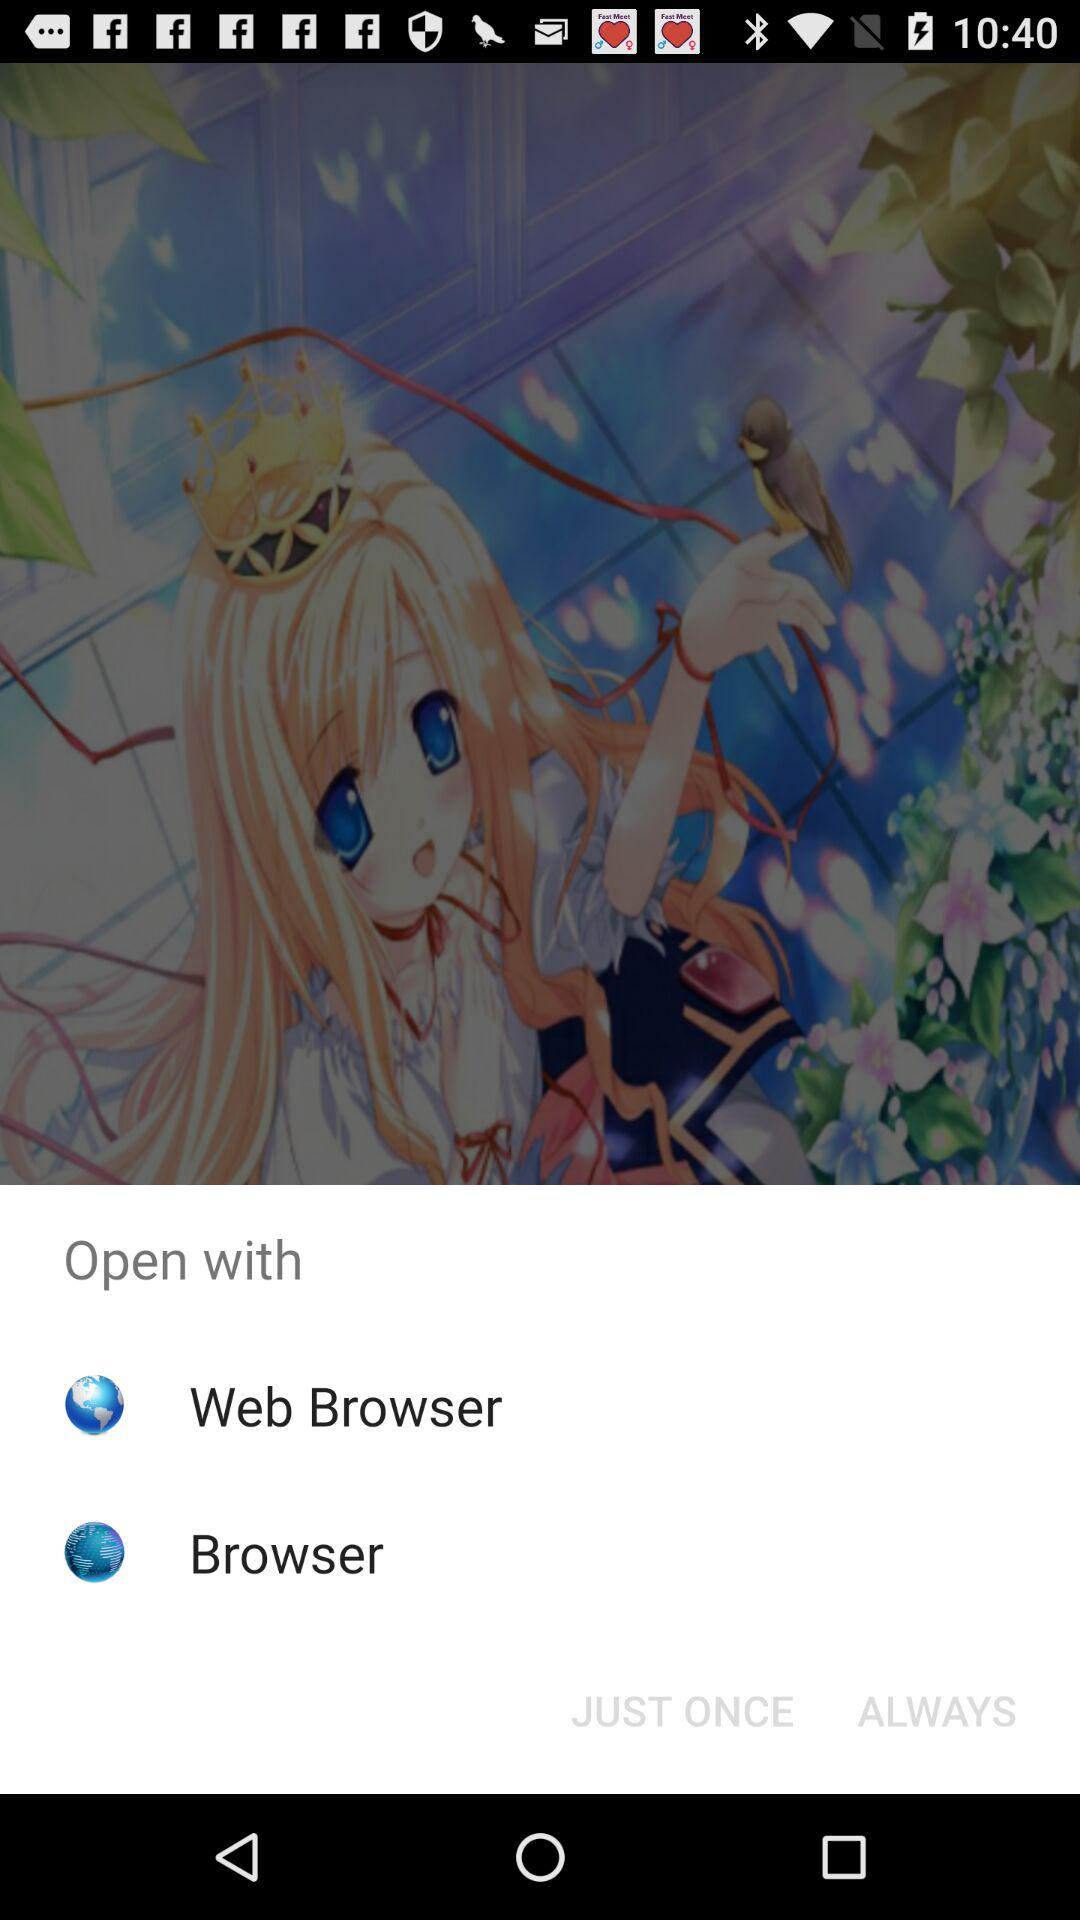Through which application can we open it? You can open it through "Web Browser" and "Browser". 